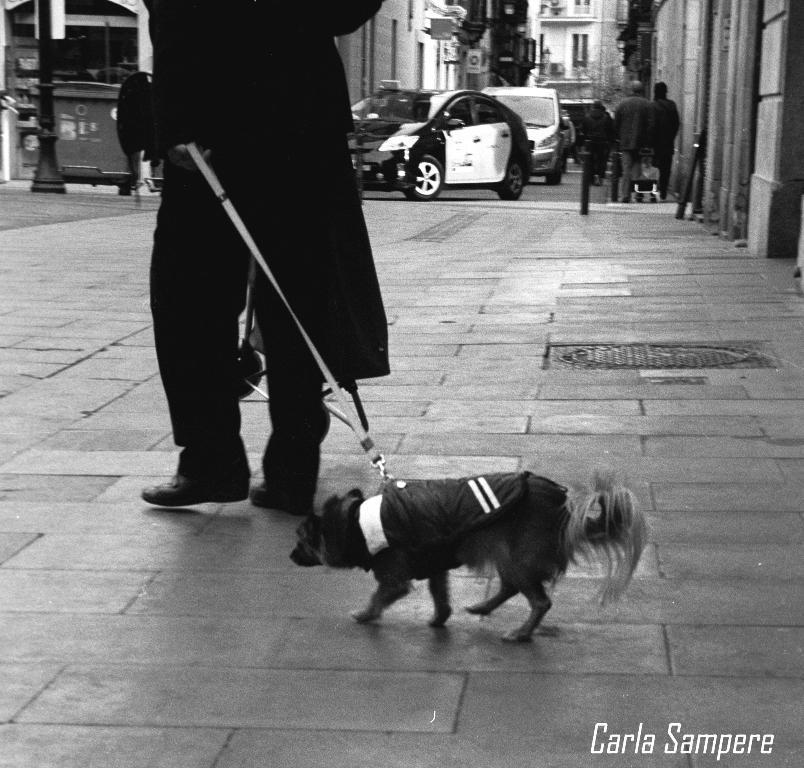How would you summarize this image in a sentence or two? A man is walking along with a dog. 